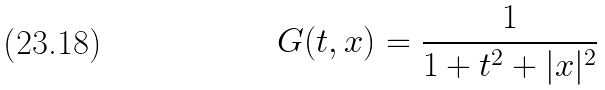Convert formula to latex. <formula><loc_0><loc_0><loc_500><loc_500>G ( t , x ) = \frac { 1 } { 1 + t ^ { 2 } + | x | ^ { 2 } }</formula> 